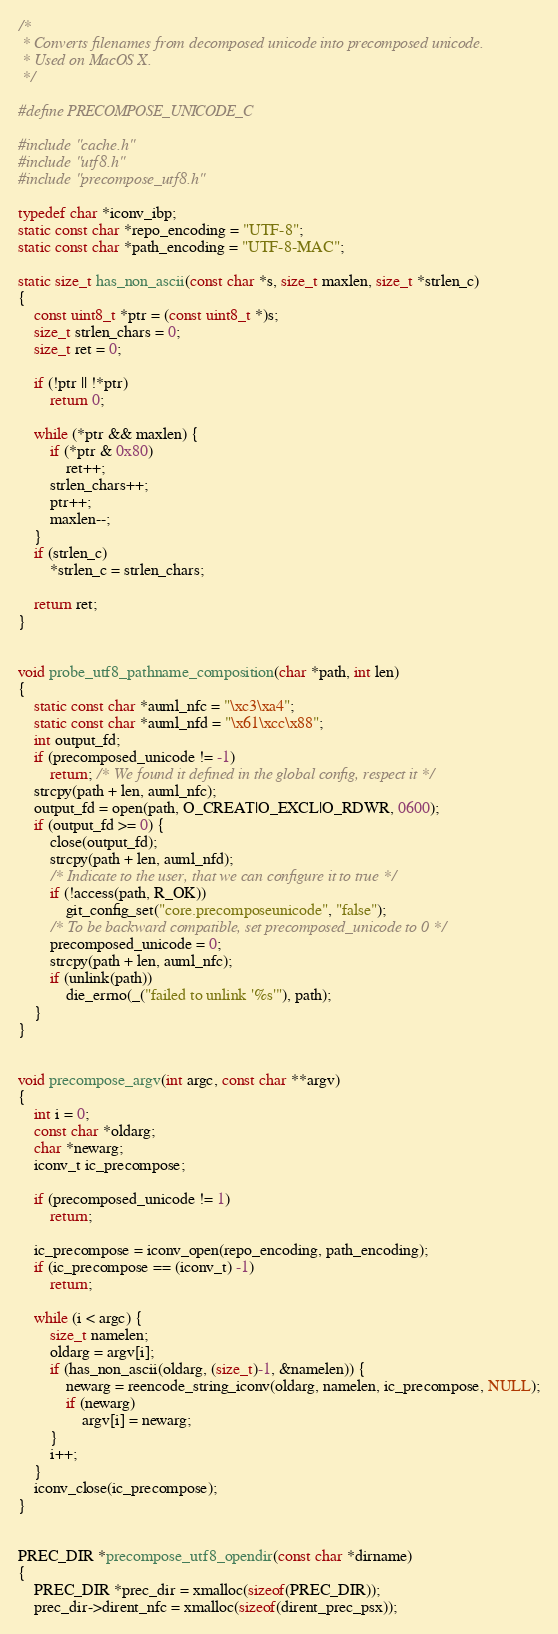<code> <loc_0><loc_0><loc_500><loc_500><_C_>/*
 * Converts filenames from decomposed unicode into precomposed unicode.
 * Used on MacOS X.
 */

#define PRECOMPOSE_UNICODE_C

#include "cache.h"
#include "utf8.h"
#include "precompose_utf8.h"

typedef char *iconv_ibp;
static const char *repo_encoding = "UTF-8";
static const char *path_encoding = "UTF-8-MAC";

static size_t has_non_ascii(const char *s, size_t maxlen, size_t *strlen_c)
{
	const uint8_t *ptr = (const uint8_t *)s;
	size_t strlen_chars = 0;
	size_t ret = 0;

	if (!ptr || !*ptr)
		return 0;

	while (*ptr && maxlen) {
		if (*ptr & 0x80)
			ret++;
		strlen_chars++;
		ptr++;
		maxlen--;
	}
	if (strlen_c)
		*strlen_c = strlen_chars;

	return ret;
}


void probe_utf8_pathname_composition(char *path, int len)
{
	static const char *auml_nfc = "\xc3\xa4";
	static const char *auml_nfd = "\x61\xcc\x88";
	int output_fd;
	if (precomposed_unicode != -1)
		return; /* We found it defined in the global config, respect it */
	strcpy(path + len, auml_nfc);
	output_fd = open(path, O_CREAT|O_EXCL|O_RDWR, 0600);
	if (output_fd >= 0) {
		close(output_fd);
		strcpy(path + len, auml_nfd);
		/* Indicate to the user, that we can configure it to true */
		if (!access(path, R_OK))
			git_config_set("core.precomposeunicode", "false");
		/* To be backward compatible, set precomposed_unicode to 0 */
		precomposed_unicode = 0;
		strcpy(path + len, auml_nfc);
		if (unlink(path))
			die_errno(_("failed to unlink '%s'"), path);
	}
}


void precompose_argv(int argc, const char **argv)
{
	int i = 0;
	const char *oldarg;
	char *newarg;
	iconv_t ic_precompose;

	if (precomposed_unicode != 1)
		return;

	ic_precompose = iconv_open(repo_encoding, path_encoding);
	if (ic_precompose == (iconv_t) -1)
		return;

	while (i < argc) {
		size_t namelen;
		oldarg = argv[i];
		if (has_non_ascii(oldarg, (size_t)-1, &namelen)) {
			newarg = reencode_string_iconv(oldarg, namelen, ic_precompose, NULL);
			if (newarg)
				argv[i] = newarg;
		}
		i++;
	}
	iconv_close(ic_precompose);
}


PREC_DIR *precompose_utf8_opendir(const char *dirname)
{
	PREC_DIR *prec_dir = xmalloc(sizeof(PREC_DIR));
	prec_dir->dirent_nfc = xmalloc(sizeof(dirent_prec_psx));</code> 